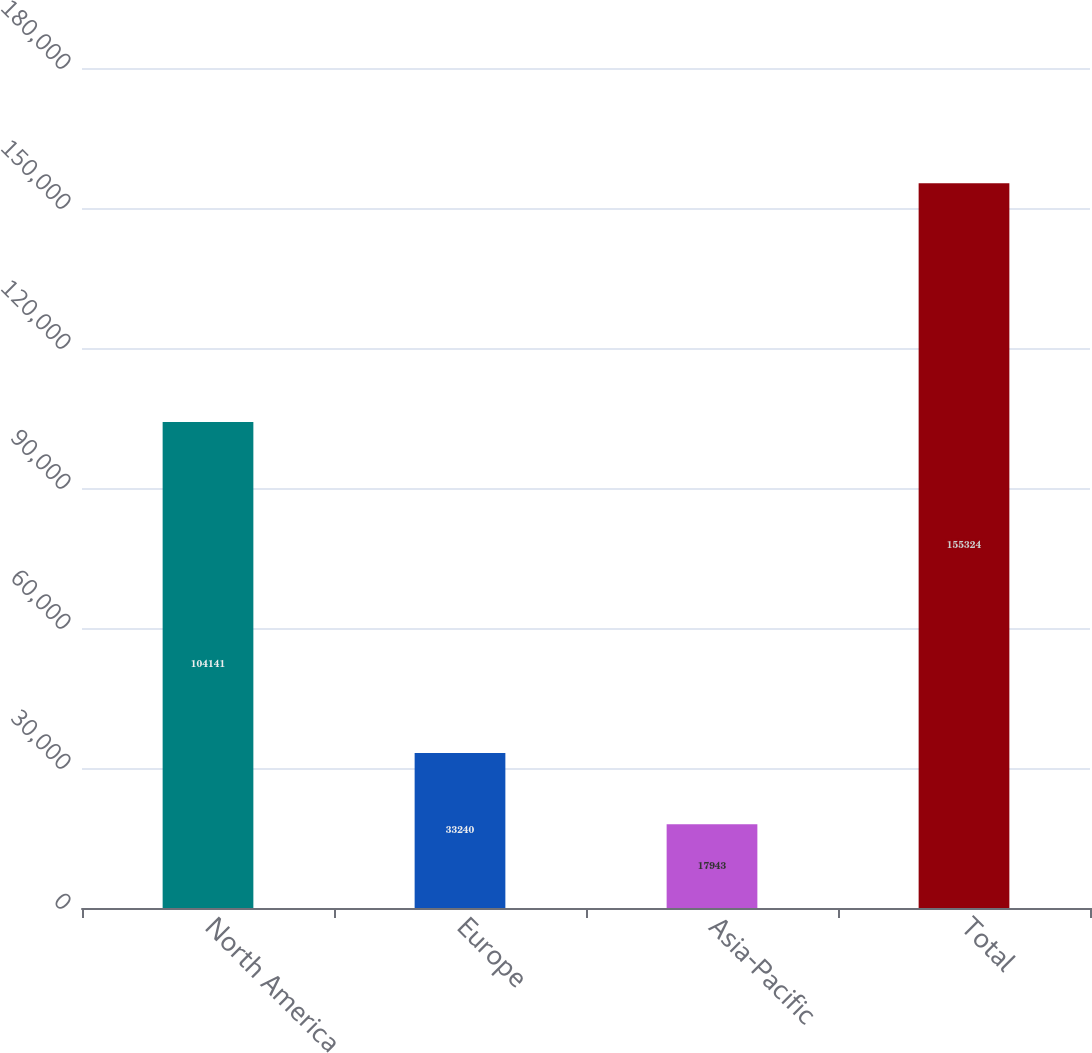Convert chart. <chart><loc_0><loc_0><loc_500><loc_500><bar_chart><fcel>North America<fcel>Europe<fcel>Asia-Pacific<fcel>Total<nl><fcel>104141<fcel>33240<fcel>17943<fcel>155324<nl></chart> 